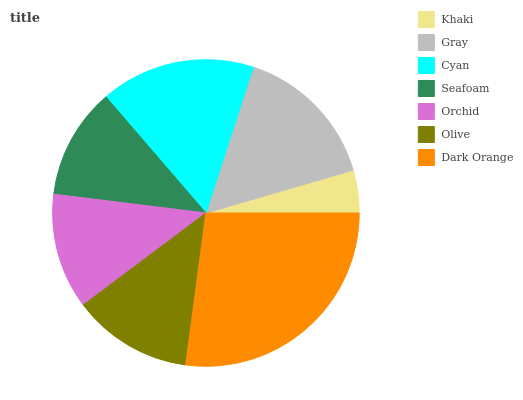Is Khaki the minimum?
Answer yes or no. Yes. Is Dark Orange the maximum?
Answer yes or no. Yes. Is Gray the minimum?
Answer yes or no. No. Is Gray the maximum?
Answer yes or no. No. Is Gray greater than Khaki?
Answer yes or no. Yes. Is Khaki less than Gray?
Answer yes or no. Yes. Is Khaki greater than Gray?
Answer yes or no. No. Is Gray less than Khaki?
Answer yes or no. No. Is Olive the high median?
Answer yes or no. Yes. Is Olive the low median?
Answer yes or no. Yes. Is Gray the high median?
Answer yes or no. No. Is Gray the low median?
Answer yes or no. No. 